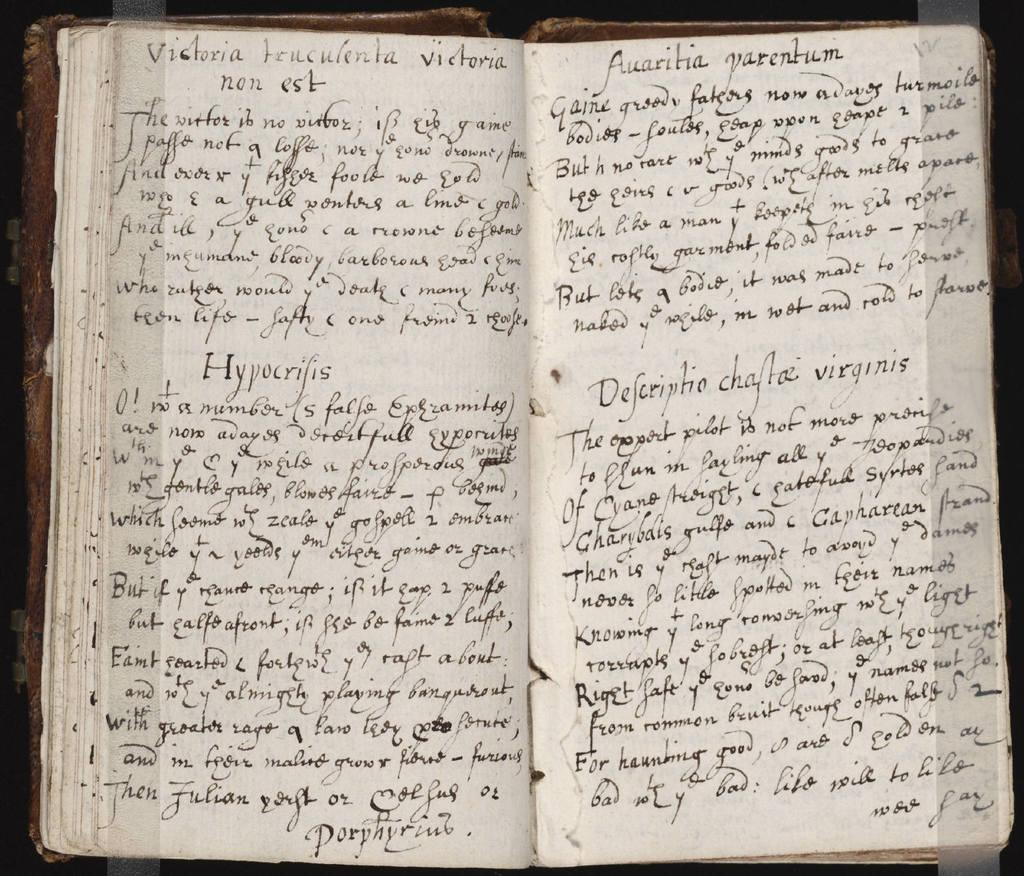Provide a one-sentence caption for the provided image. an antique book has a decsriptio chaftaz virginis inside. 